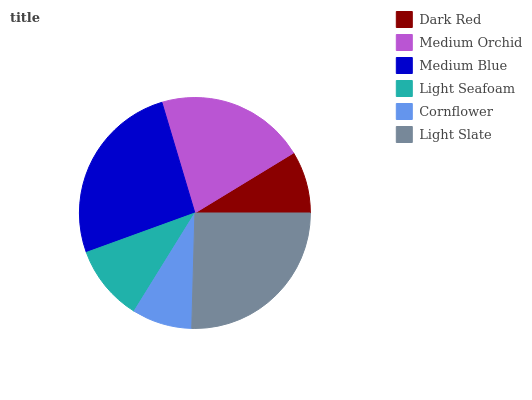Is Cornflower the minimum?
Answer yes or no. Yes. Is Medium Blue the maximum?
Answer yes or no. Yes. Is Medium Orchid the minimum?
Answer yes or no. No. Is Medium Orchid the maximum?
Answer yes or no. No. Is Medium Orchid greater than Dark Red?
Answer yes or no. Yes. Is Dark Red less than Medium Orchid?
Answer yes or no. Yes. Is Dark Red greater than Medium Orchid?
Answer yes or no. No. Is Medium Orchid less than Dark Red?
Answer yes or no. No. Is Medium Orchid the high median?
Answer yes or no. Yes. Is Light Seafoam the low median?
Answer yes or no. Yes. Is Light Slate the high median?
Answer yes or no. No. Is Medium Blue the low median?
Answer yes or no. No. 